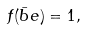Convert formula to latex. <formula><loc_0><loc_0><loc_500><loc_500>f ( \bar { b } e ) = 1 ,</formula> 